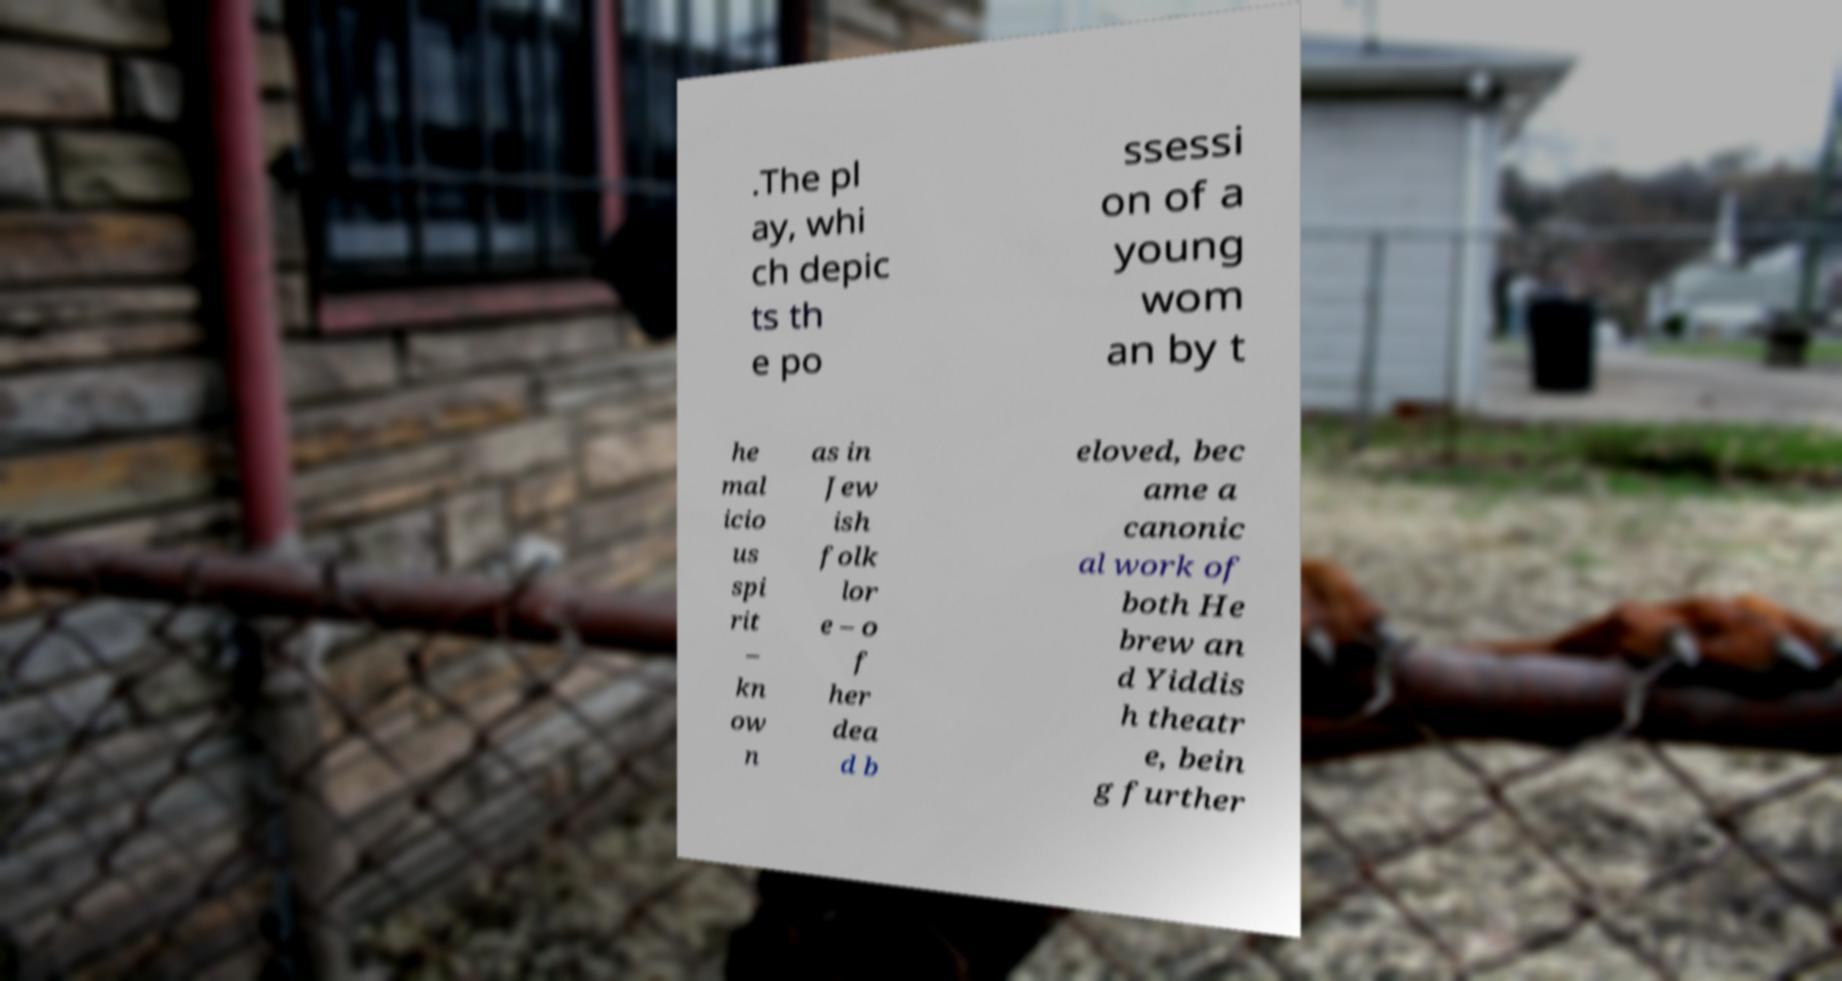Could you assist in decoding the text presented in this image and type it out clearly? .The pl ay, whi ch depic ts th e po ssessi on of a young wom an by t he mal icio us spi rit – kn ow n as in Jew ish folk lor e – o f her dea d b eloved, bec ame a canonic al work of both He brew an d Yiddis h theatr e, bein g further 